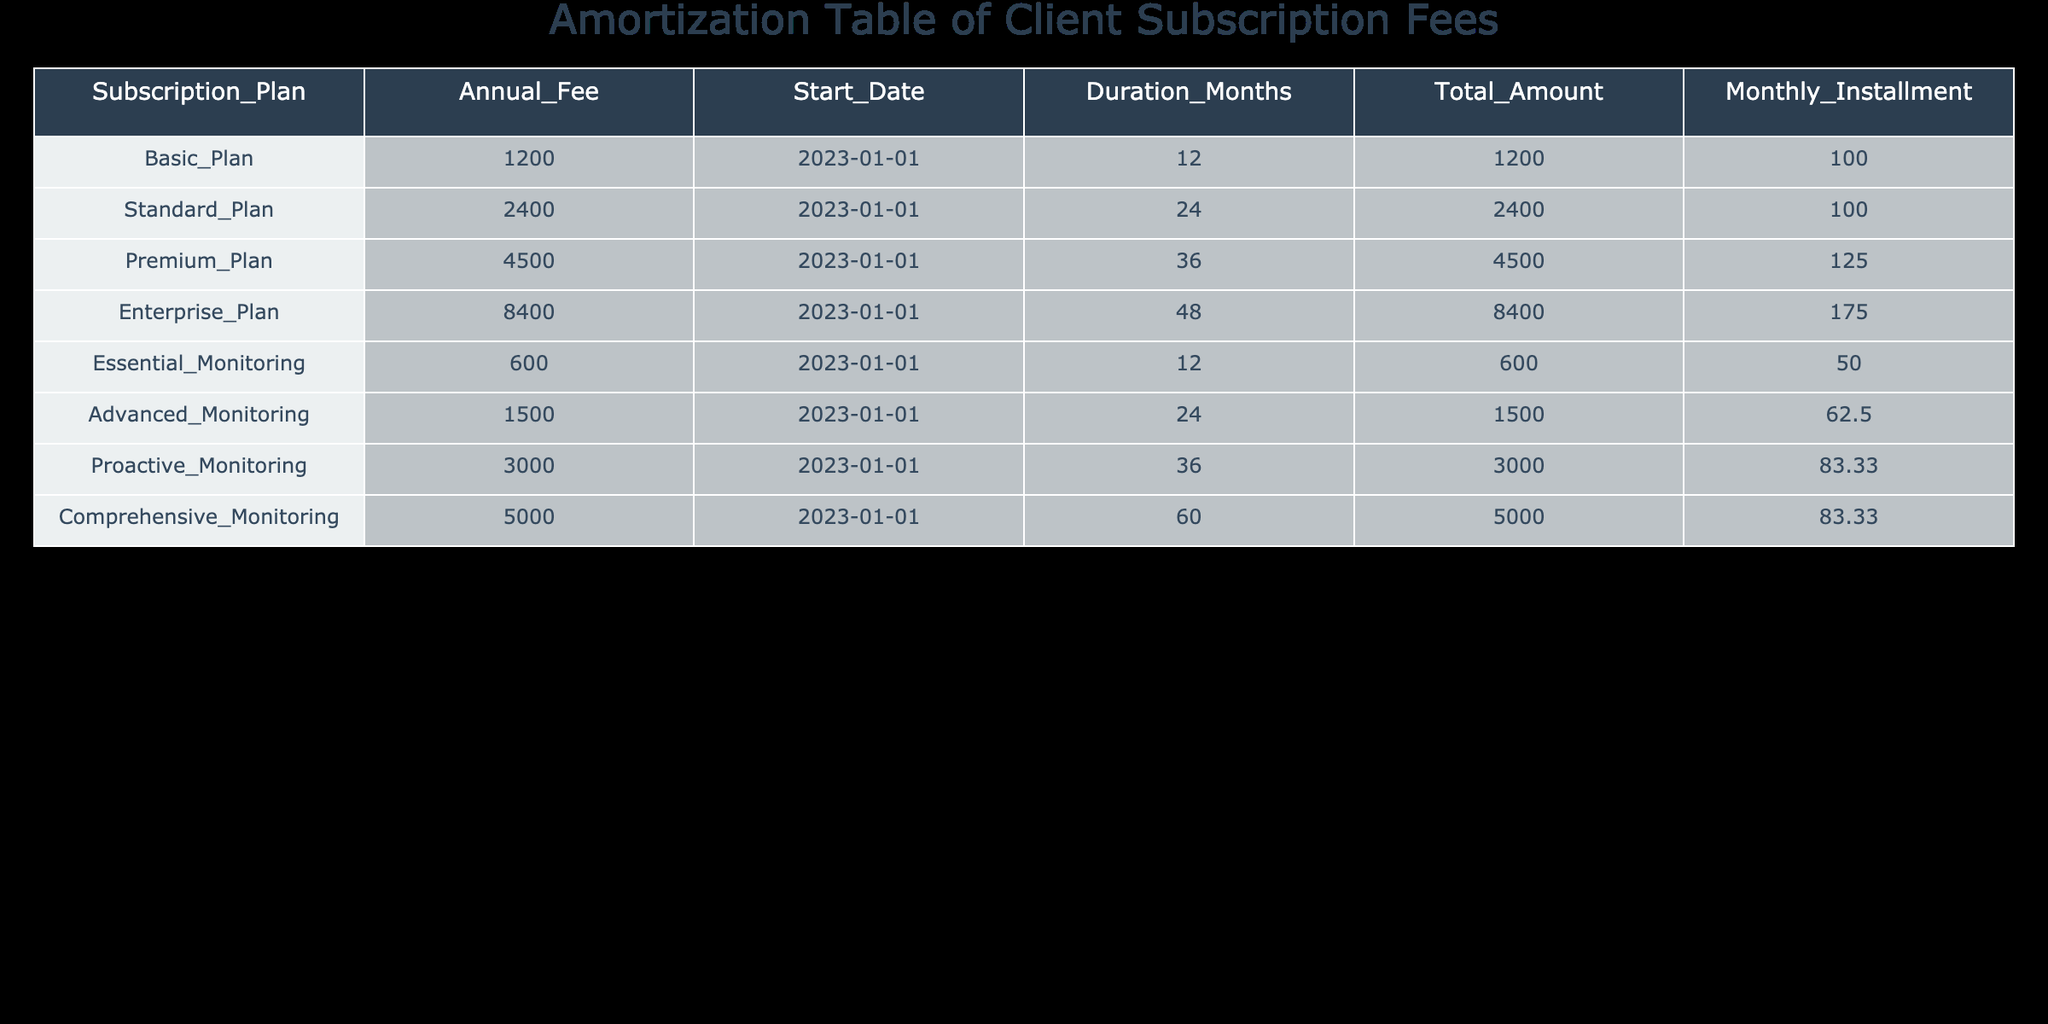What is the monthly installment for the Premium Plan? The Premium Plan is listed in the table with a monthly installment value of 125. Therefore, the monthly installment for the Premium Plan is directly taken from the table.
Answer: 125 How long is the duration of the Comprehensive Monitoring service? The table shows that Comprehensive Monitoring has a duration of 60 months. This can be retrieved directly from the relevant column in the table.
Answer: 60 months What is the total amount for the Standard Plan and the Premium Plan combined? The Standard Plan has a total amount of 2400, and the Premium Plan has a total amount of 4500. Adding these together gives 2400 + 4500 = 6900, which is the combined total amount.
Answer: 6900 Is the monthly installment for the Basic Plan greater than that of the Essential Monitoring service? The Basic Plan has a monthly installment of 100, while the Essential Monitoring service has a monthly installment of 50. Since 100 is greater than 50, the answer is yes.
Answer: Yes What is the average annual fee of all the listed subscription plans? The Annual Fees for the plans are 1200, 2400, 4500, 8400, 600, 1500, 3000, and 5000. The total annual fees sum up to 24000 and there are 8 plans, so the average is calculated as 24000/8 = 3000.
Answer: 3000 What plan has the highest monthly installment, and what is that amount? By examining the monthly installments, it can be seen that the Enterprise Plan has the highest installment at 175. This is determined by comparing all monthly installment values in the table.
Answer: Enterprise Plan, 175 If a client chooses the Advanced Monitoring plan, what is the total amount they will pay compared to the Essential Monitoring? The Advanced Monitoring plan has a total amount of 1500, while the Essential Monitoring has a total amount of 600. The difference is 1500 - 600 = 900, indicating that the Advanced Monitoring plan costs 900 more.
Answer: 900 more Is there any subscription plan longer than 36 months? Upon reviewing the durations, the Enterprise Plan (48 months) and Comprehensive Monitoring (60 months) are both longer than 36 months, confirming that there are such plans.
Answer: Yes 